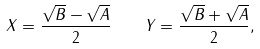<formula> <loc_0><loc_0><loc_500><loc_500>X = \frac { \sqrt { B } - \sqrt { A } } { 2 } \quad Y = \frac { \sqrt { B } + \sqrt { A } } { 2 } ,</formula> 